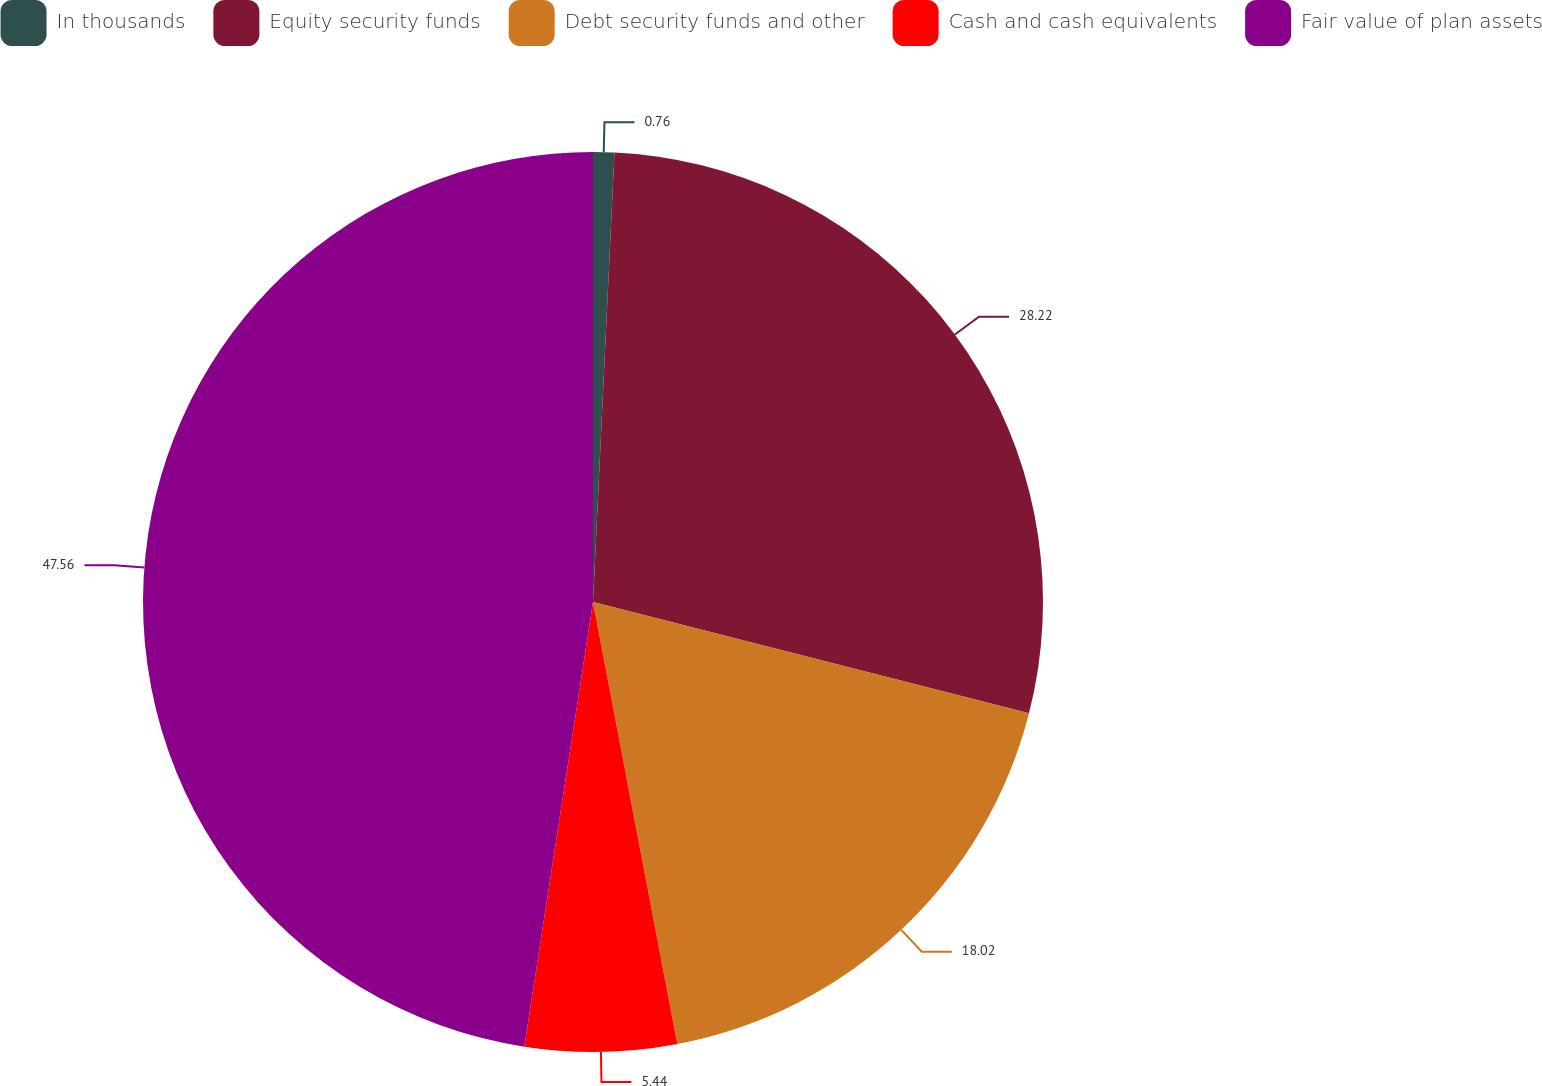Convert chart to OTSL. <chart><loc_0><loc_0><loc_500><loc_500><pie_chart><fcel>In thousands<fcel>Equity security funds<fcel>Debt security funds and other<fcel>Cash and cash equivalents<fcel>Fair value of plan assets<nl><fcel>0.76%<fcel>28.22%<fcel>18.02%<fcel>5.44%<fcel>47.56%<nl></chart> 